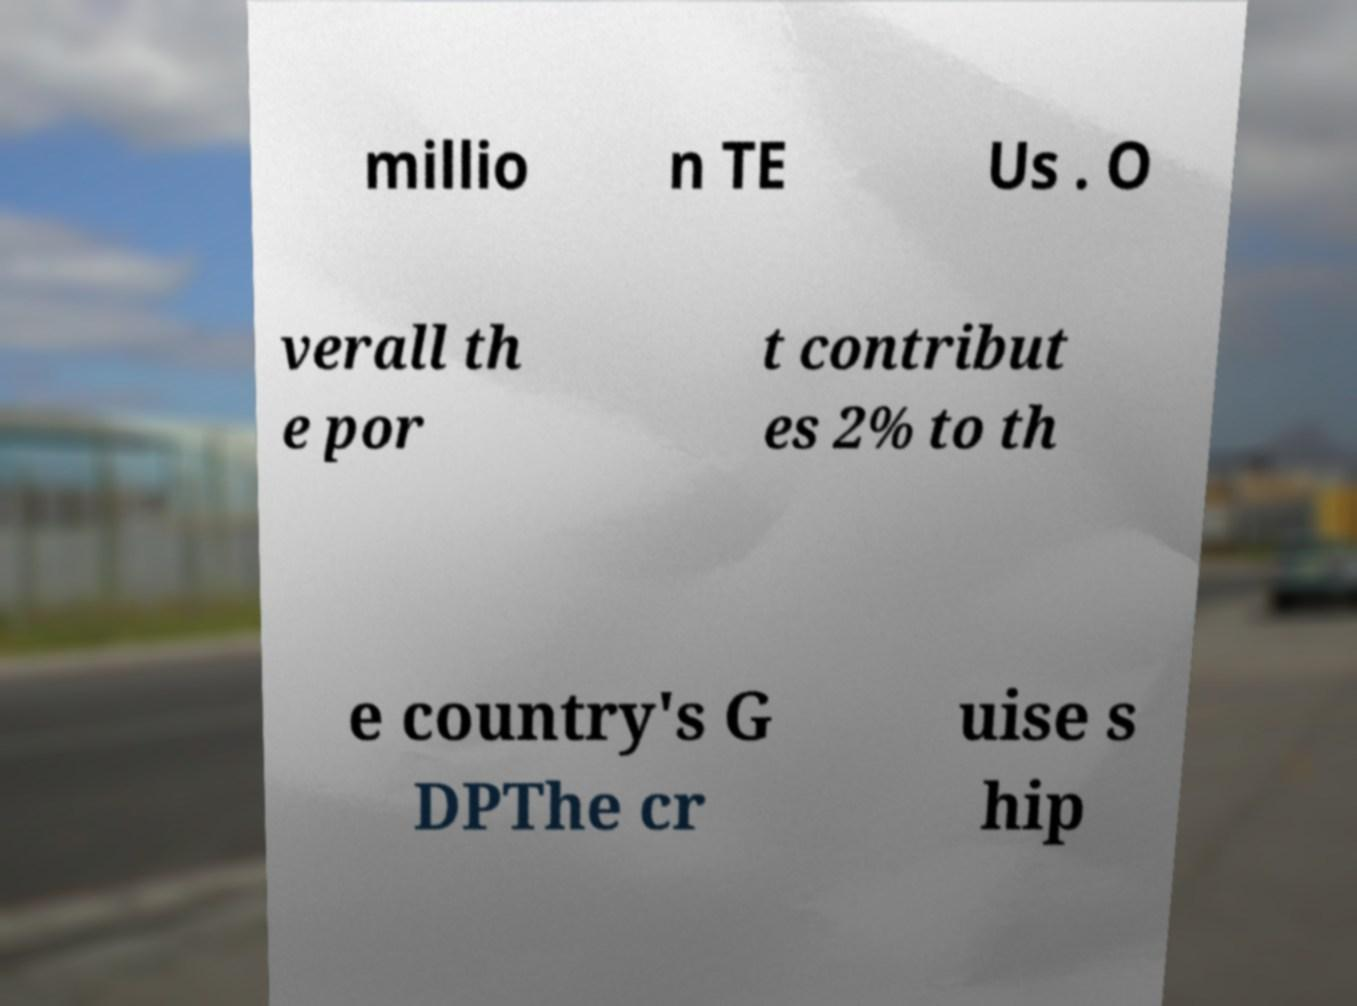For documentation purposes, I need the text within this image transcribed. Could you provide that? millio n TE Us . O verall th e por t contribut es 2% to th e country's G DPThe cr uise s hip 